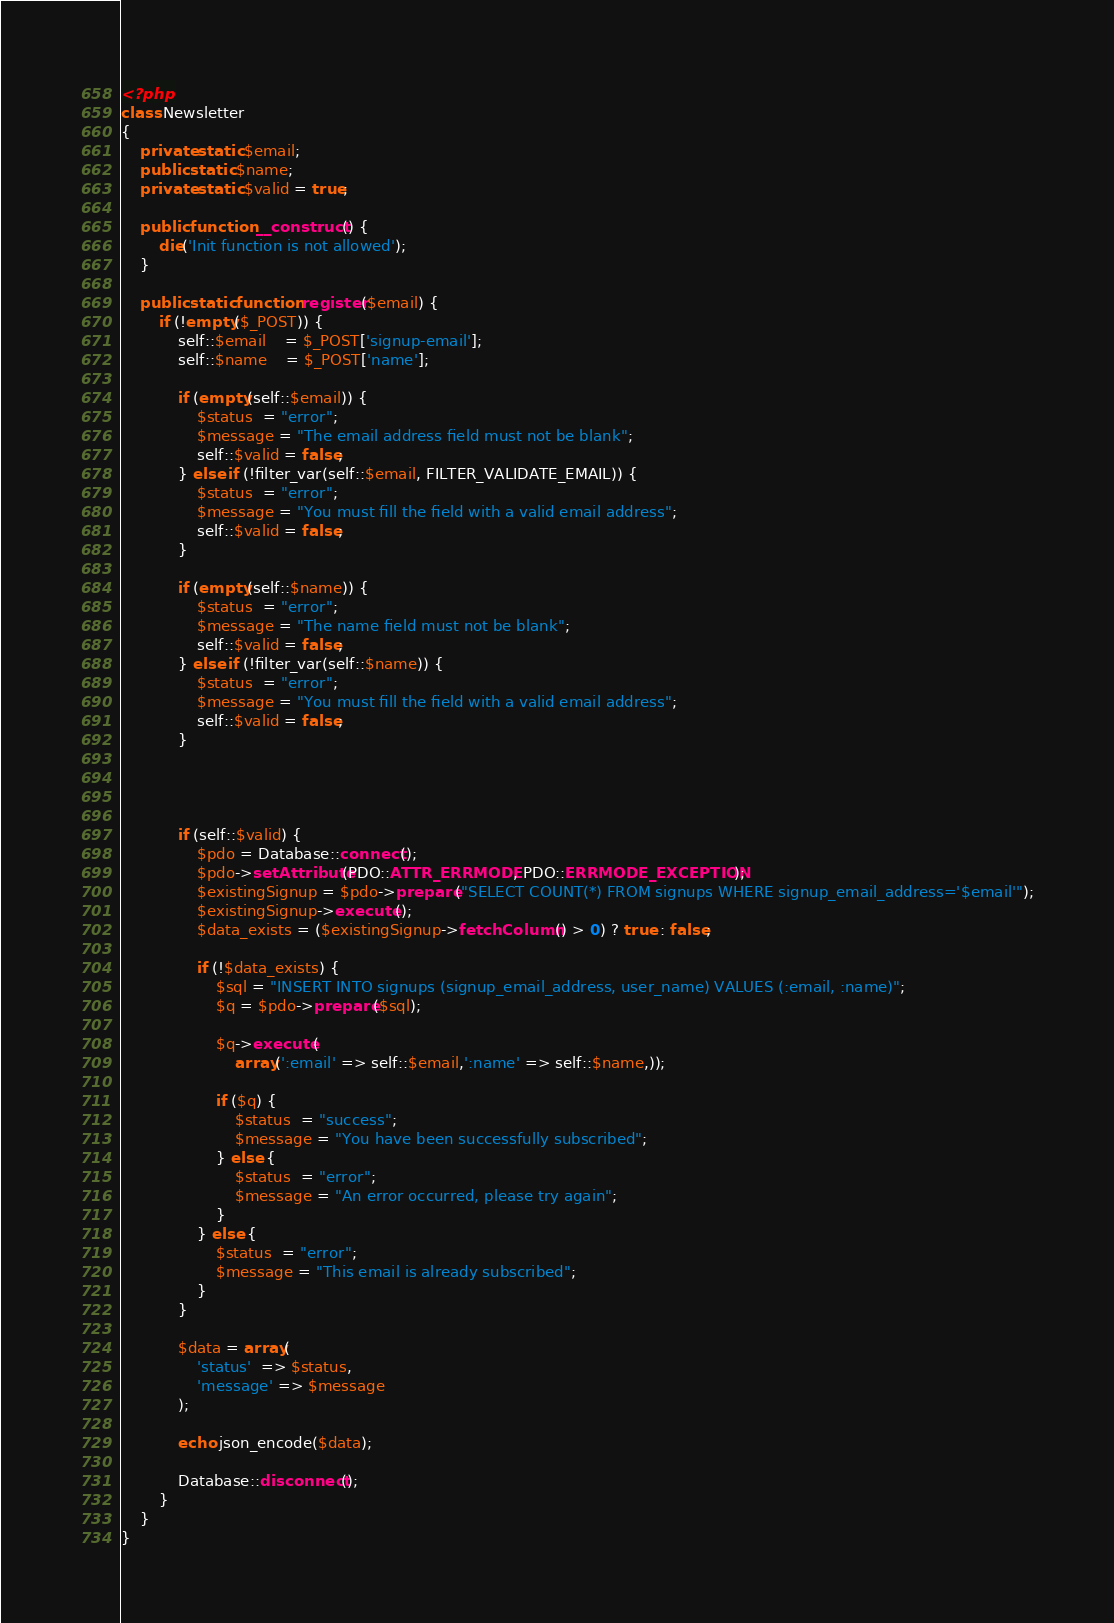Convert code to text. <code><loc_0><loc_0><loc_500><loc_500><_PHP_><?php
class Newsletter
{
    private static $email;
    public static $name;
    private static $valid = true;

    public function __construct() {
        die('Init function is not allowed');
    }

    public static function register($email) {
        if (!empty($_POST)) {
            self::$email    = $_POST['signup-email'];
            self::$name    = $_POST['name'];

            if (empty(self::$email)) {
                $status  = "error";
                $message = "The email address field must not be blank";
                self::$valid = false;
            } else if (!filter_var(self::$email, FILTER_VALIDATE_EMAIL)) {
                $status  = "error";
                $message = "You must fill the field with a valid email address";
                self::$valid = false;
            }

            if (empty(self::$name)) {
                $status  = "error";
                $message = "The name field must not be blank";
                self::$valid = false;
            } else if (!filter_var(self::$name)) {
                $status  = "error";
                $message = "You must fill the field with a valid email address";
                self::$valid = false;
            }




            if (self::$valid) {
                $pdo = Database::connect();
                $pdo->setAttribute(PDO::ATTR_ERRMODE, PDO::ERRMODE_EXCEPTION);
                $existingSignup = $pdo->prepare("SELECT COUNT(*) FROM signups WHERE signup_email_address='$email'");
                $existingSignup->execute();
                $data_exists = ($existingSignup->fetchColumn() > 0) ? true : false;

                if (!$data_exists) {
                    $sql = "INSERT INTO signups (signup_email_address, user_name) VALUES (:email, :name)";
                    $q = $pdo->prepare($sql);

                    $q->execute(
                        array(':email' => self::$email,':name' => self::$name,));

                    if ($q) {
                        $status  = "success";
                        $message = "You have been successfully subscribed";
                    } else {
                        $status  = "error";
                        $message = "An error occurred, please try again";
                    }
                } else {
                    $status  = "error";
                    $message = "This email is already subscribed";
                }
            }

            $data = array(
                'status'  => $status,
                'message' => $message
            );

            echo json_encode($data);

            Database::disconnect();
        }
    }
}</code> 